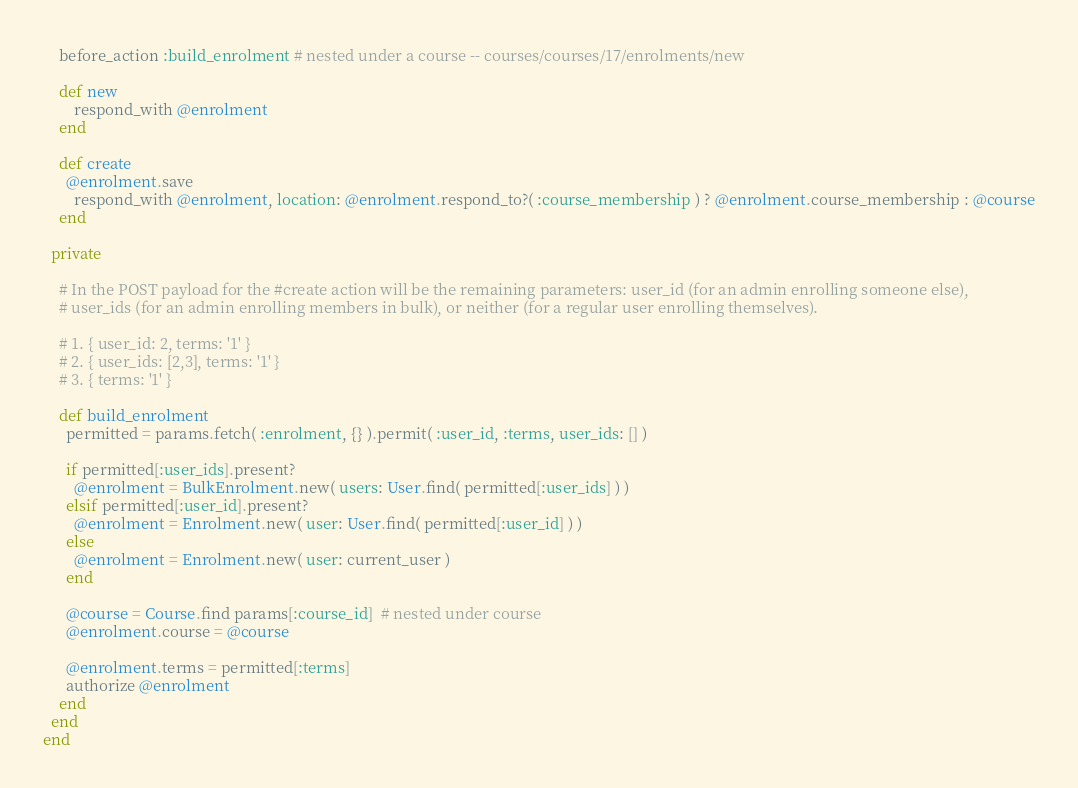Convert code to text. <code><loc_0><loc_0><loc_500><loc_500><_Ruby_>
    before_action :build_enrolment # nested under a course -- courses/courses/17/enrolments/new

    def new
    	respond_with @enrolment
    end

    def create
      @enrolment.save
    	respond_with @enrolment, location: @enrolment.respond_to?( :course_membership ) ? @enrolment.course_membership : @course
    end

  private

    # In the POST payload for the #create action will be the remaining parameters: user_id (for an admin enrolling someone else), 
    # user_ids (for an admin enrolling members in bulk), or neither (for a regular user enrolling themselves).

    # 1. { user_id: 2, terms: '1' }
    # 2. { user_ids: [2,3], terms: '1' }
    # 3. { terms: '1' }

    def build_enrolment
      permitted = params.fetch( :enrolment, {} ).permit( :user_id, :terms, user_ids: [] )

      if permitted[:user_ids].present?
        @enrolment = BulkEnrolment.new( users: User.find( permitted[:user_ids] ) )
      elsif permitted[:user_id].present?
        @enrolment = Enrolment.new( user: User.find( permitted[:user_id] ) )
      else
        @enrolment = Enrolment.new( user: current_user )
      end

      @course = Course.find params[:course_id]  # nested under course
      @enrolment.course = @course

      @enrolment.terms = permitted[:terms]
      authorize @enrolment
    end
  end
end
</code> 